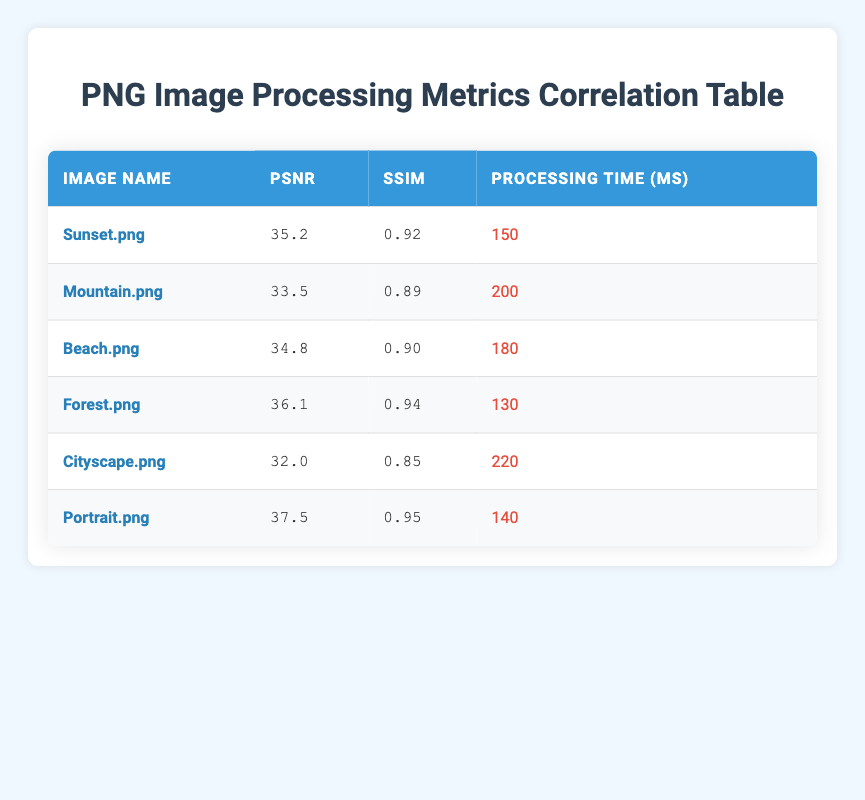What is the PSNR value for the image "Portrait.png"? The table lists the PSNR values for all images. Looking at the row for "Portrait.png," the PSNR value is noted as 37.5.
Answer: 37.5 Which image has the lowest SSIM value? The SSIM values for all images are listed. Scanning through the SSIM values, "Cityscape.png" has the lowest value of 0.85.
Answer: Cityscape.png What is the average Processing Time for the images in the table? To calculate the average Processing Time, sum all the times: (150 + 200 + 180 + 130 + 220 + 140) = 1020. There are 6 images, so the average is 1020 / 6 = 170.
Answer: 170 Is the Processing Time for "Forest.png" less than the average Processing Time for the images? The Processing Time for "Forest.png" is 130 ms, while the average is 170 ms. Since 130 is less than 170, the answer is yes.
Answer: Yes What is the difference in PSNR between the highest and lowest PSNR images? The highest PSNR value is for "Portrait.png" at 37.5, and the lowest is for "Cityscape.png" at 32.0. The difference is 37.5 - 32.0 = 5.5.
Answer: 5.5 Which image has the best quality metrics overall? To determine the best quality metrics, we can look for the highest PSNR and SSIM values together. "Portrait.png" has the highest PSNR (37.5) and SSIM (0.95), so it has the best quality metrics overall.
Answer: Portrait.png How does the Processing Time for "Beach.png" compare to "Mountain.png"? "Beach.png" has a Processing Time of 180 ms, while "Mountain.png" has 200 ms. 180 ms is less than 200 ms, indicating that "Beach.png" is processed faster.
Answer: Beach.png is faster Is there an image with a PSNR greater than 36 and a Processing Time less than 160 ms? The images with PSNR greater than 36 are "Forest.png" (36.1) and "Portrait.png" (37.5). "Forest.png" has a Processing Time of 130 ms, which is less than 160 ms, thus meeting the criteria.
Answer: Yes What is the median SSIM value for all images? First, list the SSIM values in order: 0.85, 0.89, 0.90, 0.92, 0.94, 0.95. There are 6 values. The median is the average of the 3rd and 4th values: (0.90 + 0.92) / 2 = 0.91.
Answer: 0.91 